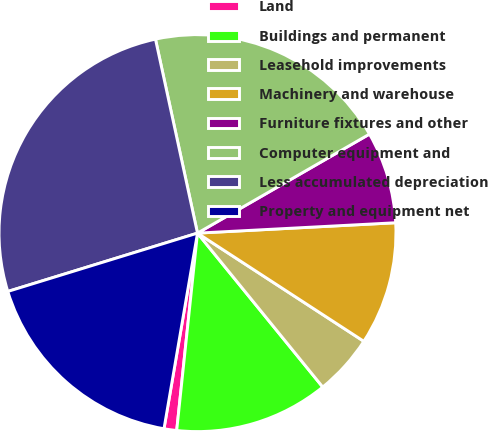<chart> <loc_0><loc_0><loc_500><loc_500><pie_chart><fcel>Land<fcel>Buildings and permanent<fcel>Leasehold improvements<fcel>Machinery and warehouse<fcel>Furniture fixtures and other<fcel>Computer equipment and<fcel>Less accumulated depreciation<fcel>Property and equipment net<nl><fcel>1.03%<fcel>12.54%<fcel>4.95%<fcel>10.01%<fcel>7.48%<fcel>20.08%<fcel>26.35%<fcel>17.55%<nl></chart> 